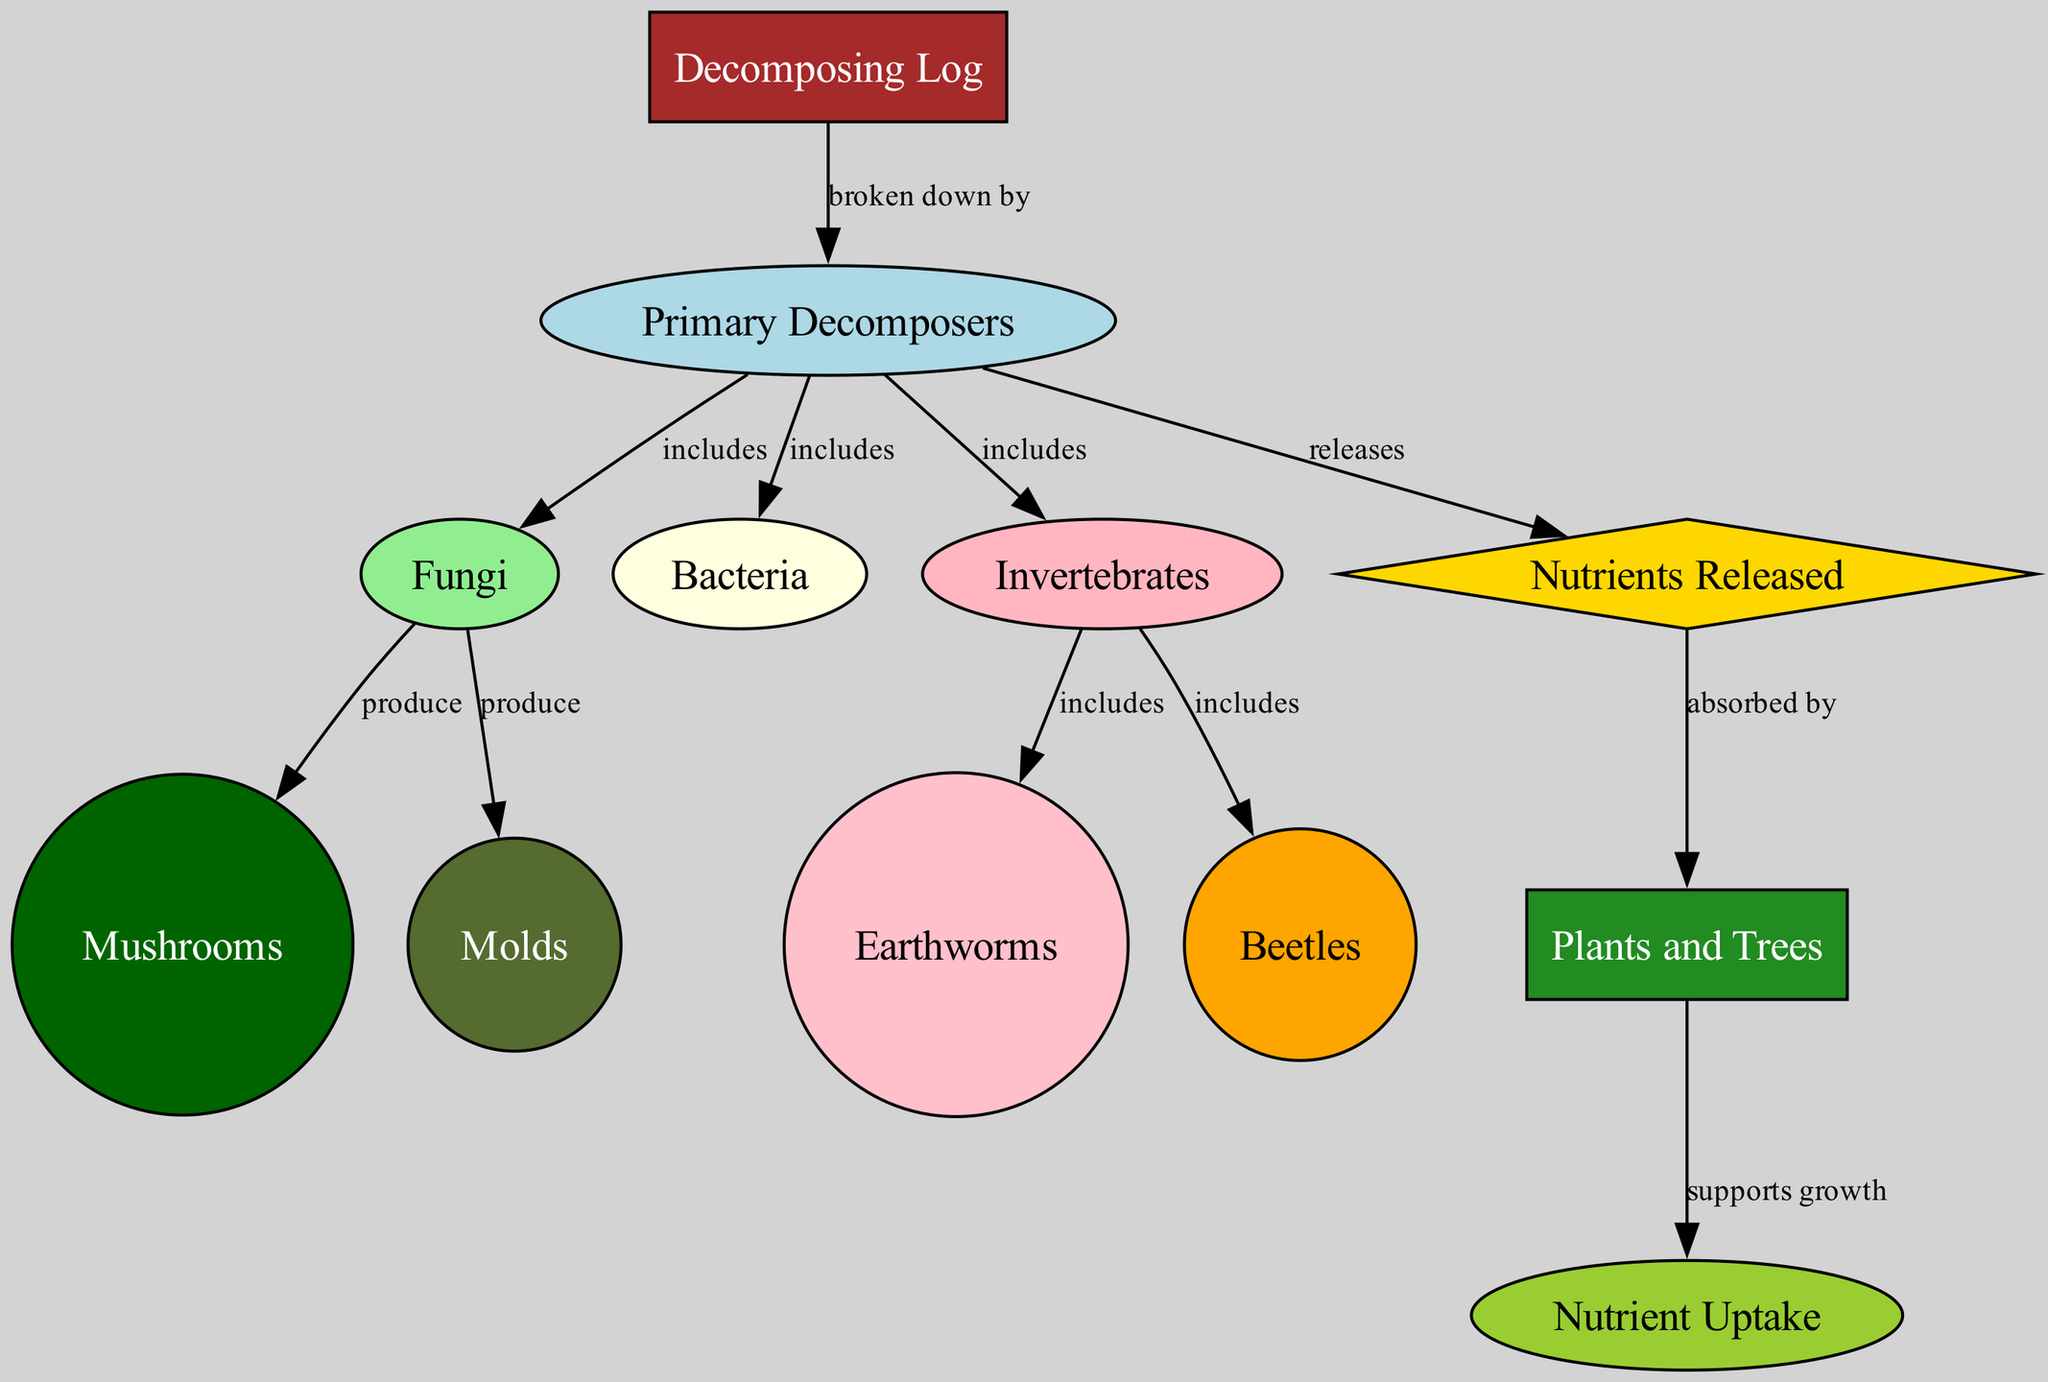What is the primary decomposer of the decomposing log? The diagram specifies that the decomposing log is broken down by primary decomposers, which include fungi, bacteria, and invertebrates. Out of these, fungi is highlighted as a significant category of primary decomposer.
Answer: Fungi How many nodes are present in the diagram? By counting the distinct labeled entities in the nodes section, we find there are 12 unique nodes, including components like decomposing log, primary decomposers, and various organism types.
Answer: 12 What do fungi produce in the decomposition process? The diagram shows that fungi produce mushrooms and molds as part of their role in decomposing organic matter. The direct relationship is indicated by the edge that connects fungi to these produced entities.
Answer: Mushrooms and molds What comes after nutrients released in the decomposition process? The nutrients released from the decomposing log are absorbed by plants and trees, as indicated by the directed edge that flows from nutrients released to plants and trees in the diagram.
Answer: Plants and trees Which invertebrate is included in the decomposition process? Invertebrates, as a category, include specific organisms like earthworms and beetles, as shown in the diagram. Choosing one, earthworms are a notable mention as an important type of invertebrate in the process.
Answer: Earthworms How do nutrients support the ecosystem in the diagram? The flow of the diagram shows that the nutrients released are absorbed by plants and trees, which further supports their growth, suggesting a critical link in the ecosystem's nutrient cycle.
Answer: Supports growth What type of edge connects the decomposing log to the primary decomposers? The relationship is described by a directed edge labeled "broken down by," indicating the flow of decomposition from the log to those decomposers.
Answer: Broken down by What color represents fungi in the diagram? The diagram uses a light green color to represent fungi, as indicated in the node style specifications for that label.
Answer: Light green 